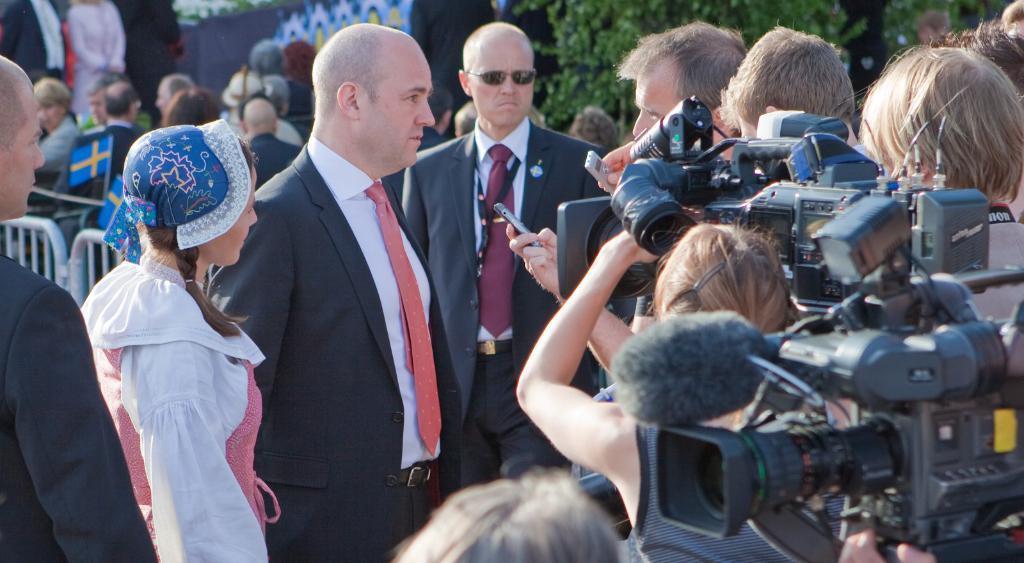Describe this image in one or two sentences. In this image we can see group of persons standing. One person is wearing a coat and tie. One woman is wearing a white dress and cap. To the right side of the image we can see a person holding camera in his hand. In the background, we can see the group of flags, metal barricade, group of trees. 